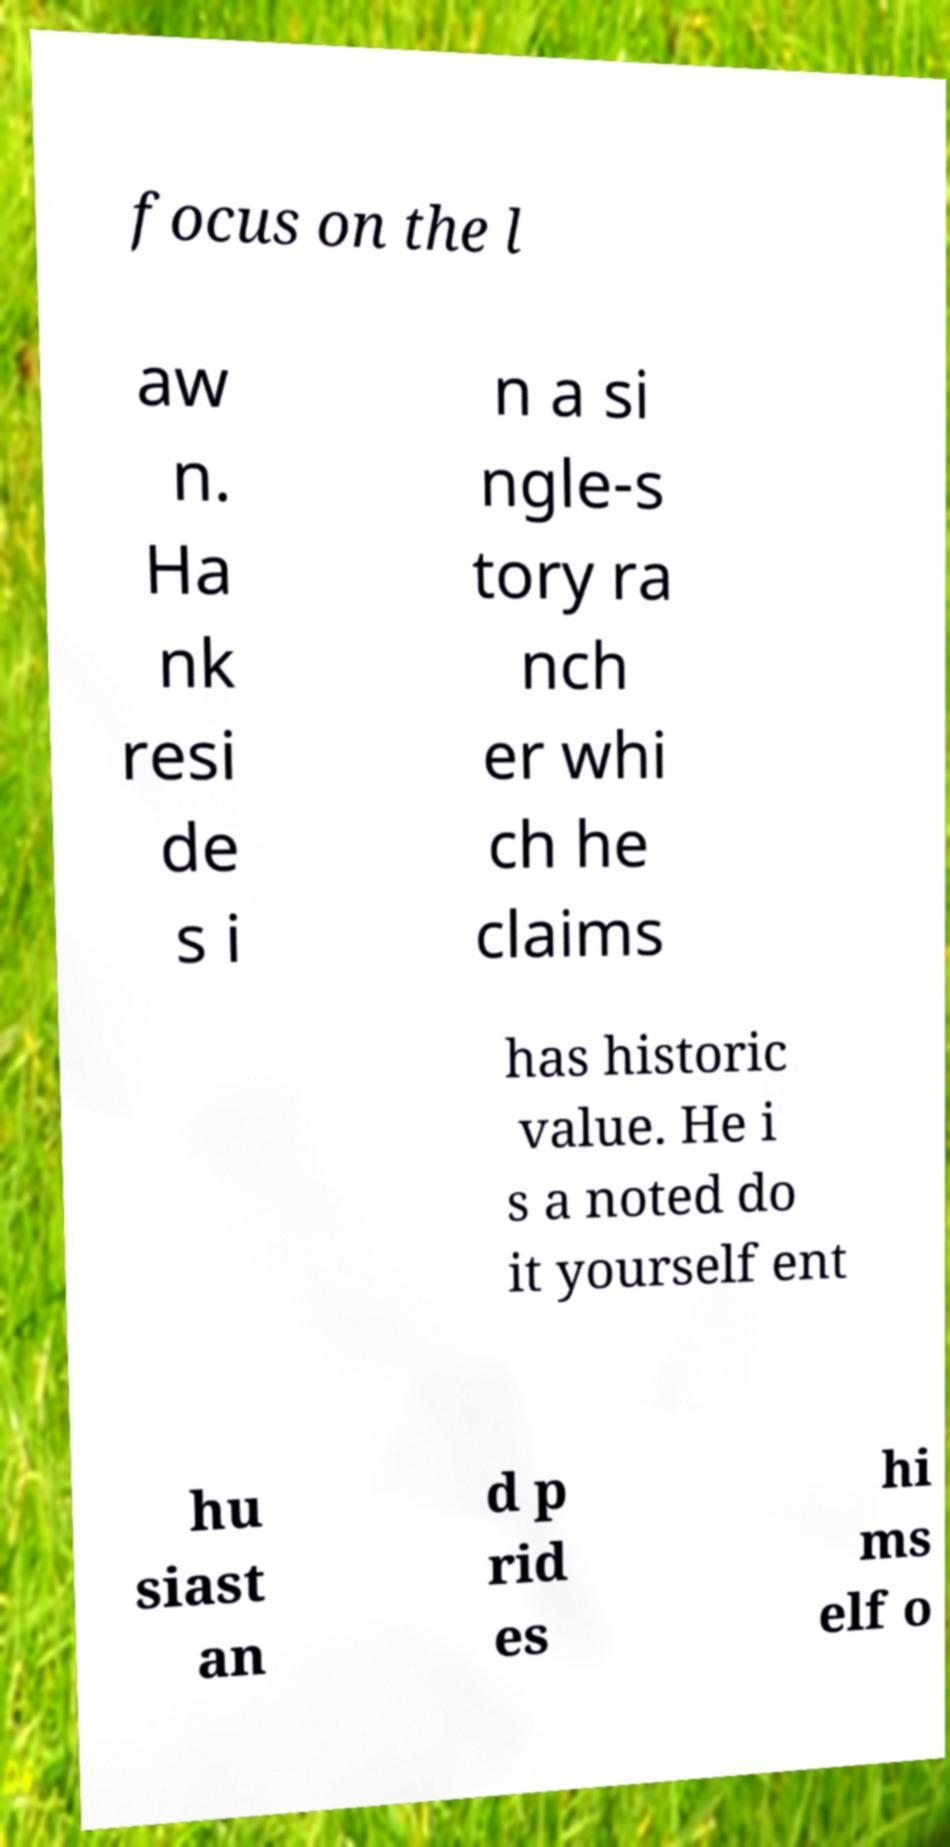What messages or text are displayed in this image? I need them in a readable, typed format. focus on the l aw n. Ha nk resi de s i n a si ngle-s tory ra nch er whi ch he claims has historic value. He i s a noted do it yourself ent hu siast an d p rid es hi ms elf o 